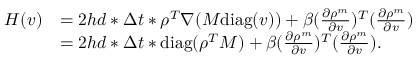<formula> <loc_0><loc_0><loc_500><loc_500>\begin{array} { r l } { H ( v ) } & { = 2 h d * \Delta t * \rho ^ { T } \nabla ( M d i a g ( v ) ) + \beta ( \frac { \partial \rho ^ { m } } { \partial v } ) ^ { T } ( \frac { \partial \rho ^ { m } } { \partial v } ) } \\ & { = 2 h d * \Delta t * d i a g ( \rho ^ { T } M ) + \beta ( \frac { \partial \rho ^ { m } } { \partial v } ) ^ { T } ( \frac { \partial \rho ^ { m } } { \partial v } ) . } \end{array}</formula> 